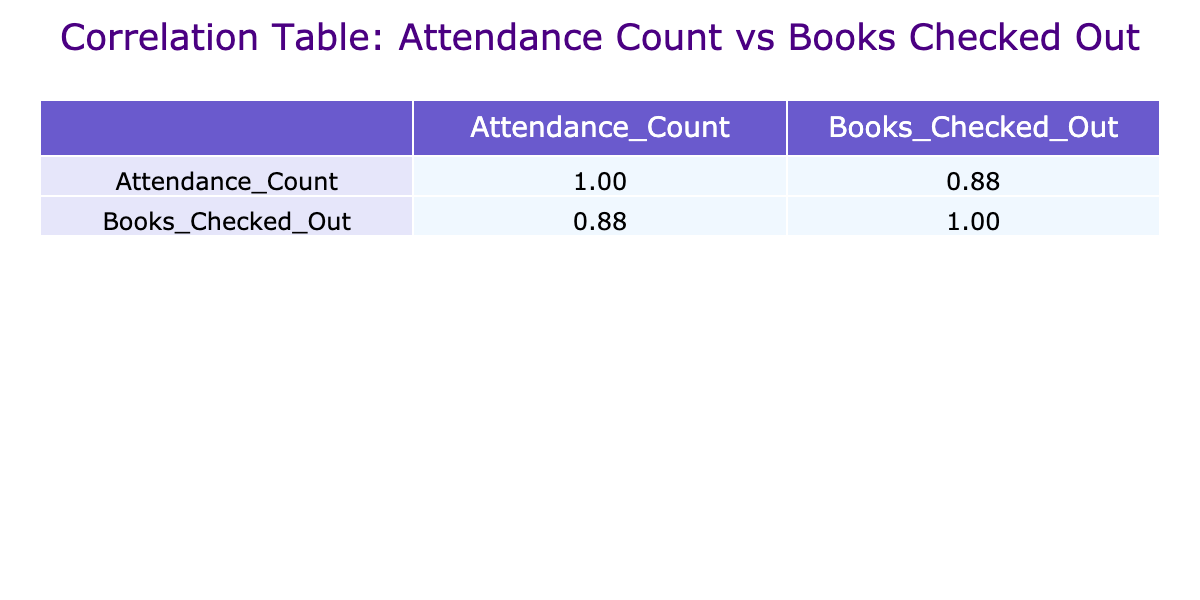What is the correlation coefficient between Attendance Count and Books Checked Out? The correlation coefficient is located in the table. Specifically, the value for Attendance Count with itself is 1.00, and the value for Attendance Count with Books Checked Out is 0.87.
Answer: 0.87 How many events had an Attendance Count greater than 80? By checking the Attendance Count for each event, the events with counts greater than 80 are: Library Book Fair (120), Community Art Workshop (100), Summer Reading Launch (110), and Haunted Library Trivia Night (95). This totals to four events.
Answer: 4 What is the average number of books checked out at the events listed? To find the average, sum the Books Checked Out for all events (30 + 20 + 60 + 15 + 40 + 35 + 25 + 45 + 70 + 10 + 20 + 50 + 30 + 40 =  455) and divide by the number of events (14). The average is 455 / 14 ≈ 32.5.
Answer: 32.5 Did the Library Book Fair have the highest Attendance Count? Comparing the Attendance Counts of all events, the Library Book Fair has the highest with 120 attendees. Therefore, this statement is true.
Answer: Yes What is the difference in average Attendance Count between events that had more than 60 books checked out versus those with 60 or fewer? First, identify the relevant events: those with more than 60 checked out are Library Book Fair (120), Summer Reading Launch (110), and Fall Book Drive (80). Their average Attendance Count is (120 + 110 + 80) / 3 = 110. The events with 60 or fewer checked out are Local Author Book Signing (75), Children's Storytime (50), Teen Poetry Slam (30), Community Art Workshop (100), Local History Night (40), Poetry and Prose Night (55), Haunted Library Trivia Night (95), and Winter Reading Celebration (70). Their average is (75 + 50 + 30 + 100 + 40 + 55 + 95 + 70) / 8 = 61.25. The difference in averages is 110 - 61.25 = 48.75.
Answer: 48.75 How many events had fewer than 40 books checked out? By reviewing the Books Checked Out column, the events with fewer than 40 checkouts are: Teen Poetry Slam (15) and Local History Night (10). This amounts to two events.
Answer: 2 